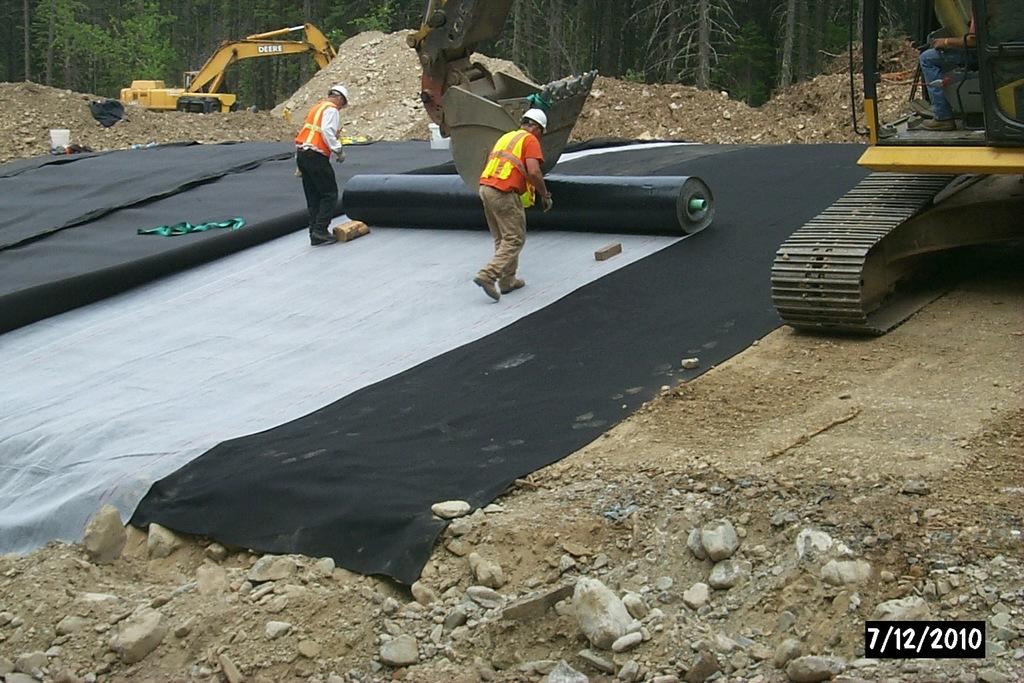What type of terrain is visible in the image? There is a land in the image. What is placed on the land? There are mats and cranes on the land. What can be seen in the background of the image? There are trees in the background of the image. What are the two persons in the image doing? Two persons are walking on the mats. Reasoning: Let' Let's think step by step in order to produce the conversation. We start by identifying the main subject in the image, which is the land. Then, we expand the conversation to include other items that are also visible, such as mats, cranes, trees, and the two persons walking. Each question is designed to elicit a specific detail about the image that is known from the provided facts. Absurd Question/Answer: What is: What type of push is being used to move the cranes in the image? There is no visible push being used to move the cranes in the image; they are stationary on the land. Can you identify the father of the two persons walking on the mats in the image? There is no information about the relationship between the two persons or their family members in the image. What type of push is being used to move the cranes in the image? There is no visible push being used to move the cranes in the image; they are stationary on the land. Can you identify the father of the two persons walking on the mats in the image? There is no information about the relationship between the two persons or their family members in the image. 